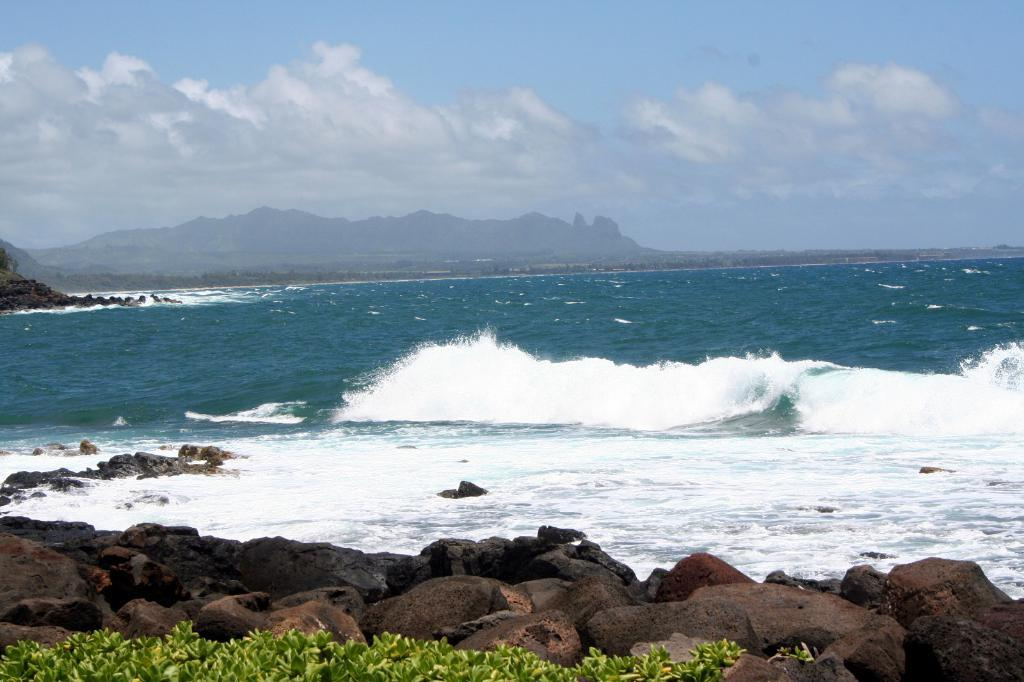What is located at the bottom of the image? There are stones and plants at the bottom of the image. What can be seen in the middle of the image? There are waves and water in the middle of the image, along with stones. What is visible in the background of the image? There are hills and sky visible in the background of the image, along with clouds. How does the person in the image help control the waves? There is no person present in the image, so there is no one to help control the waves. What type of knee injury can be seen in the image? There is no knee injury present in the image; it features stones, plants, waves, water, hills, sky, and clouds. 